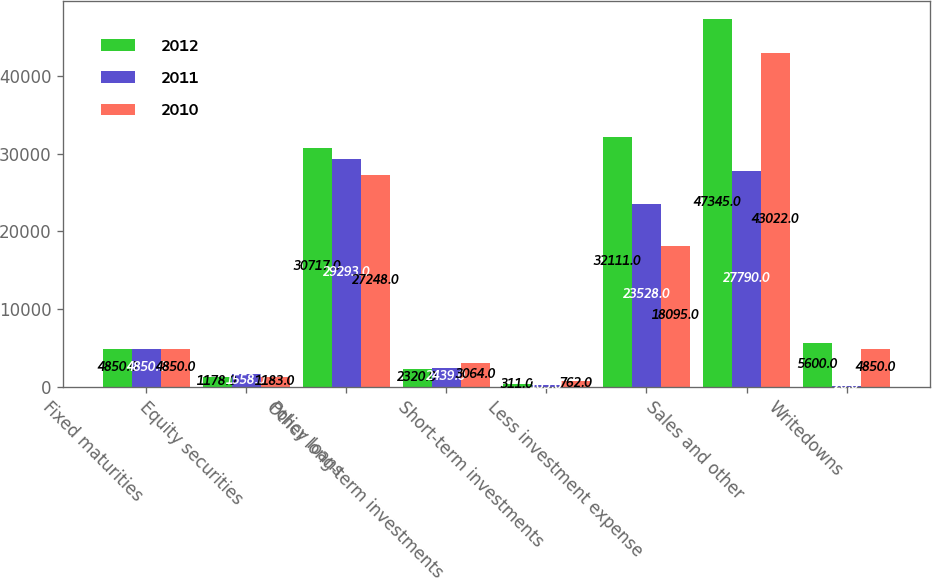<chart> <loc_0><loc_0><loc_500><loc_500><stacked_bar_chart><ecel><fcel>Fixed maturities<fcel>Equity securities<fcel>Policy loans<fcel>Other long-term investments<fcel>Short-term investments<fcel>Less investment expense<fcel>Sales and other<fcel>Writedowns<nl><fcel>2012<fcel>4850<fcel>1178<fcel>30717<fcel>2320<fcel>311<fcel>32111<fcel>47345<fcel>5600<nl><fcel>2011<fcel>4850<fcel>1558<fcel>29293<fcel>2439<fcel>165<fcel>23528<fcel>27790<fcel>20<nl><fcel>2010<fcel>4850<fcel>1183<fcel>27248<fcel>3064<fcel>762<fcel>18095<fcel>43022<fcel>4850<nl></chart> 